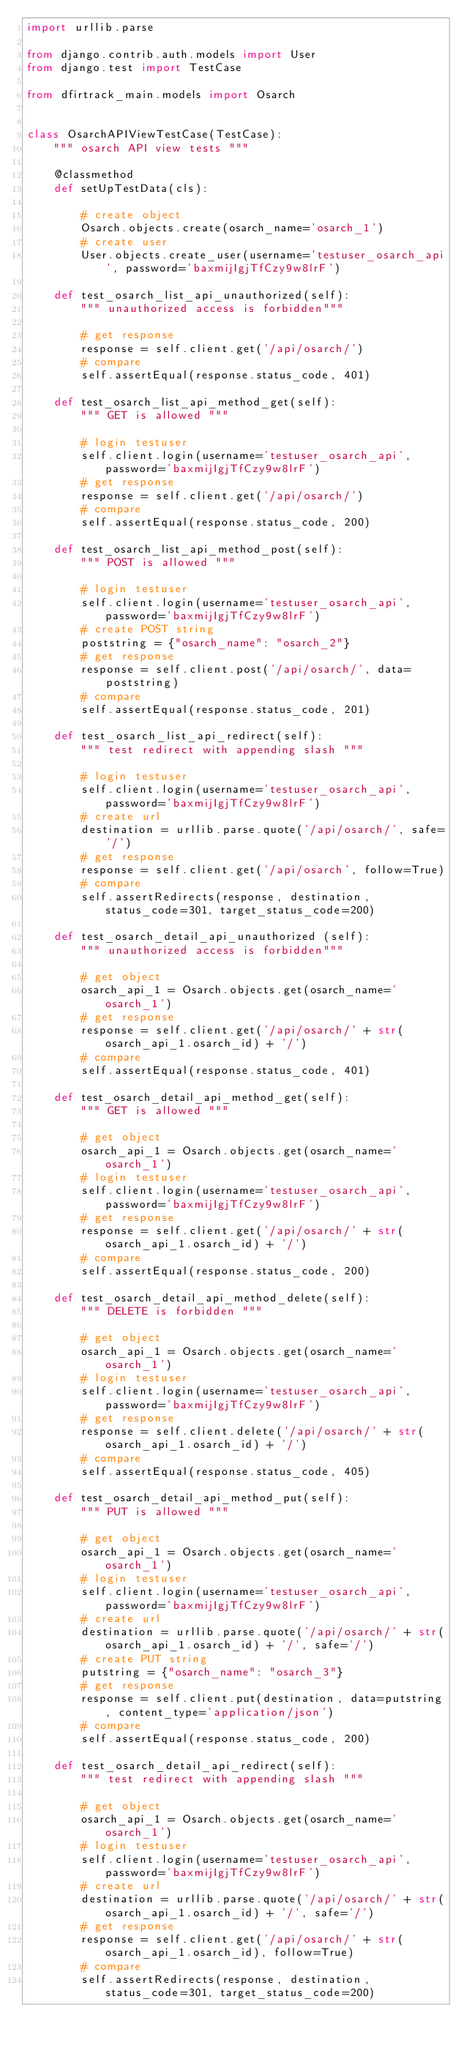<code> <loc_0><loc_0><loc_500><loc_500><_Python_>import urllib.parse

from django.contrib.auth.models import User
from django.test import TestCase

from dfirtrack_main.models import Osarch


class OsarchAPIViewTestCase(TestCase):
    """ osarch API view tests """

    @classmethod
    def setUpTestData(cls):

        # create object
        Osarch.objects.create(osarch_name='osarch_1')
        # create user
        User.objects.create_user(username='testuser_osarch_api', password='baxmijIgjTfCzy9w8lrF')

    def test_osarch_list_api_unauthorized(self):
        """ unauthorized access is forbidden"""

        # get response
        response = self.client.get('/api/osarch/')
        # compare
        self.assertEqual(response.status_code, 401)

    def test_osarch_list_api_method_get(self):
        """ GET is allowed """

        # login testuser
        self.client.login(username='testuser_osarch_api', password='baxmijIgjTfCzy9w8lrF')
        # get response
        response = self.client.get('/api/osarch/')
        # compare
        self.assertEqual(response.status_code, 200)

    def test_osarch_list_api_method_post(self):
        """ POST is allowed """

        # login testuser
        self.client.login(username='testuser_osarch_api', password='baxmijIgjTfCzy9w8lrF')
        # create POST string
        poststring = {"osarch_name": "osarch_2"}
        # get response
        response = self.client.post('/api/osarch/', data=poststring)
        # compare
        self.assertEqual(response.status_code, 201)

    def test_osarch_list_api_redirect(self):
        """ test redirect with appending slash """

        # login testuser
        self.client.login(username='testuser_osarch_api', password='baxmijIgjTfCzy9w8lrF')
        # create url
        destination = urllib.parse.quote('/api/osarch/', safe='/')
        # get response
        response = self.client.get('/api/osarch', follow=True)
        # compare
        self.assertRedirects(response, destination, status_code=301, target_status_code=200)

    def test_osarch_detail_api_unauthorized (self):
        """ unauthorized access is forbidden"""

        # get object
        osarch_api_1 = Osarch.objects.get(osarch_name='osarch_1')
        # get response
        response = self.client.get('/api/osarch/' + str(osarch_api_1.osarch_id) + '/')
        # compare
        self.assertEqual(response.status_code, 401)

    def test_osarch_detail_api_method_get(self):
        """ GET is allowed """

        # get object
        osarch_api_1 = Osarch.objects.get(osarch_name='osarch_1')
        # login testuser
        self.client.login(username='testuser_osarch_api', password='baxmijIgjTfCzy9w8lrF')
        # get response
        response = self.client.get('/api/osarch/' + str(osarch_api_1.osarch_id) + '/')
        # compare
        self.assertEqual(response.status_code, 200)

    def test_osarch_detail_api_method_delete(self):
        """ DELETE is forbidden """

        # get object
        osarch_api_1 = Osarch.objects.get(osarch_name='osarch_1')
        # login testuser
        self.client.login(username='testuser_osarch_api', password='baxmijIgjTfCzy9w8lrF')
        # get response
        response = self.client.delete('/api/osarch/' + str(osarch_api_1.osarch_id) + '/')
        # compare
        self.assertEqual(response.status_code, 405)

    def test_osarch_detail_api_method_put(self):
        """ PUT is allowed """

        # get object
        osarch_api_1 = Osarch.objects.get(osarch_name='osarch_1')
        # login testuser
        self.client.login(username='testuser_osarch_api', password='baxmijIgjTfCzy9w8lrF')
        # create url
        destination = urllib.parse.quote('/api/osarch/' + str(osarch_api_1.osarch_id) + '/', safe='/')
        # create PUT string
        putstring = {"osarch_name": "osarch_3"}
        # get response
        response = self.client.put(destination, data=putstring, content_type='application/json')
        # compare
        self.assertEqual(response.status_code, 200)

    def test_osarch_detail_api_redirect(self):
        """ test redirect with appending slash """

        # get object
        osarch_api_1 = Osarch.objects.get(osarch_name='osarch_1')
        # login testuser
        self.client.login(username='testuser_osarch_api', password='baxmijIgjTfCzy9w8lrF')
        # create url
        destination = urllib.parse.quote('/api/osarch/' + str(osarch_api_1.osarch_id) + '/', safe='/')
        # get response
        response = self.client.get('/api/osarch/' + str(osarch_api_1.osarch_id), follow=True)
        # compare
        self.assertRedirects(response, destination, status_code=301, target_status_code=200)
</code> 